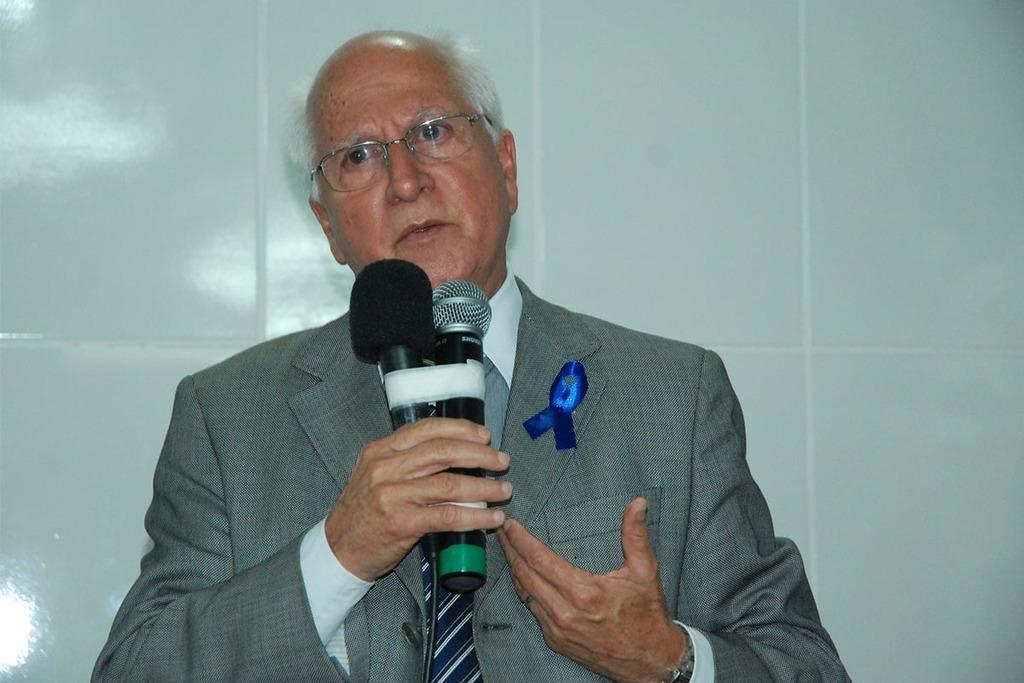Who is the main subject in the image? There is a man in the image. What is the man wearing? The man is wearing a suit. What object is the man holding in his right hand? The man is holding a microphone in his right hand. What is the man doing in the image? The man is speaking. What type of badge is the man wearing on his suit in the image? There is no badge visible on the man's suit in the image. 